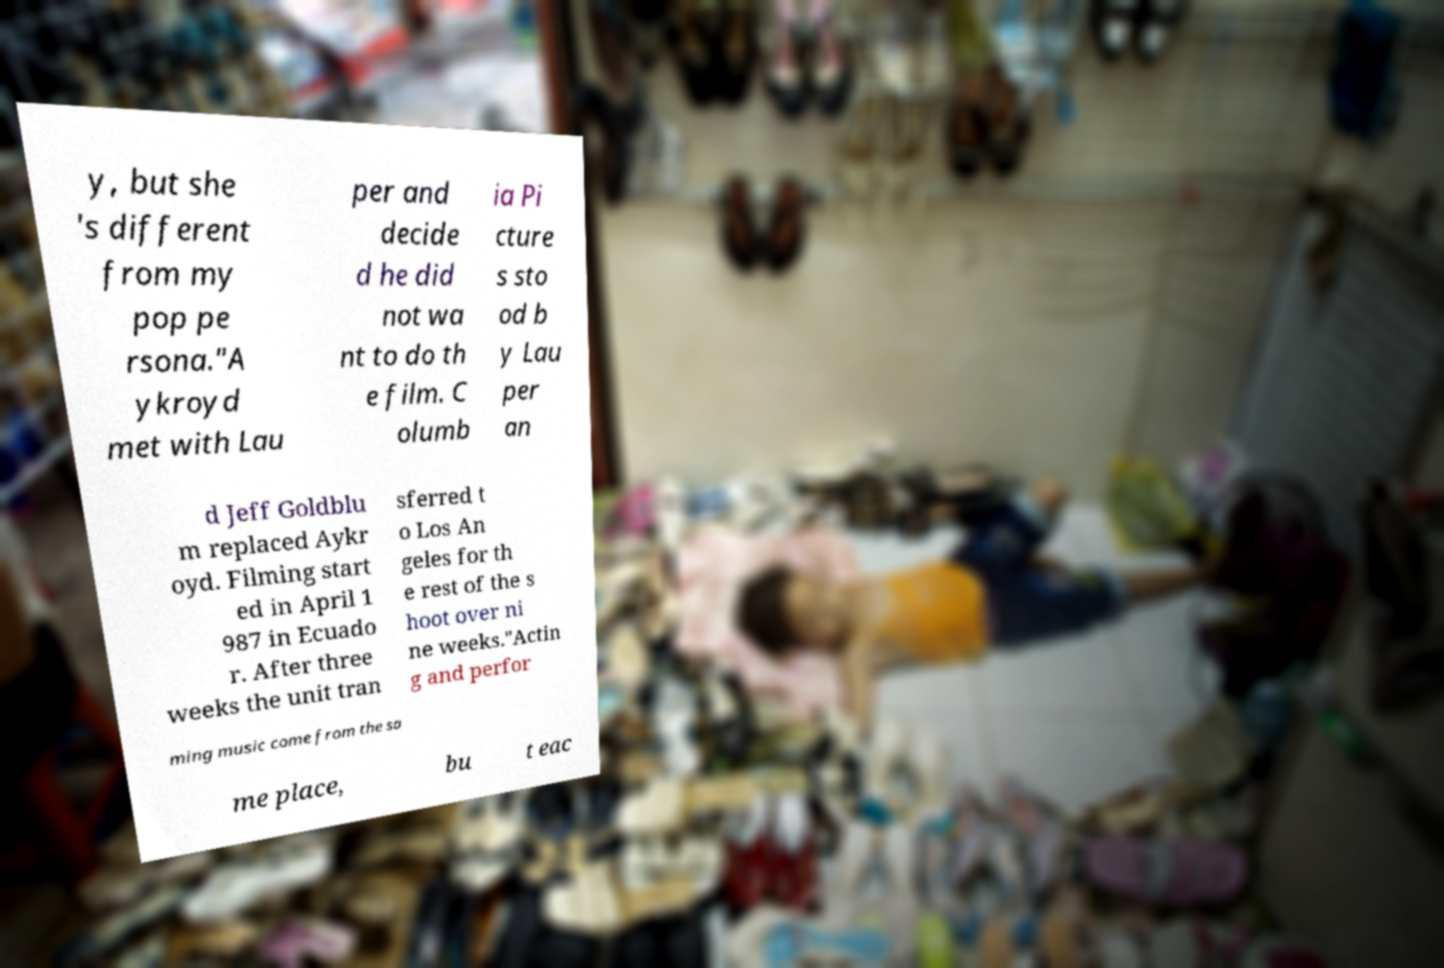Could you assist in decoding the text presented in this image and type it out clearly? y, but she 's different from my pop pe rsona."A ykroyd met with Lau per and decide d he did not wa nt to do th e film. C olumb ia Pi cture s sto od b y Lau per an d Jeff Goldblu m replaced Aykr oyd. Filming start ed in April 1 987 in Ecuado r. After three weeks the unit tran sferred t o Los An geles for th e rest of the s hoot over ni ne weeks."Actin g and perfor ming music come from the sa me place, bu t eac 